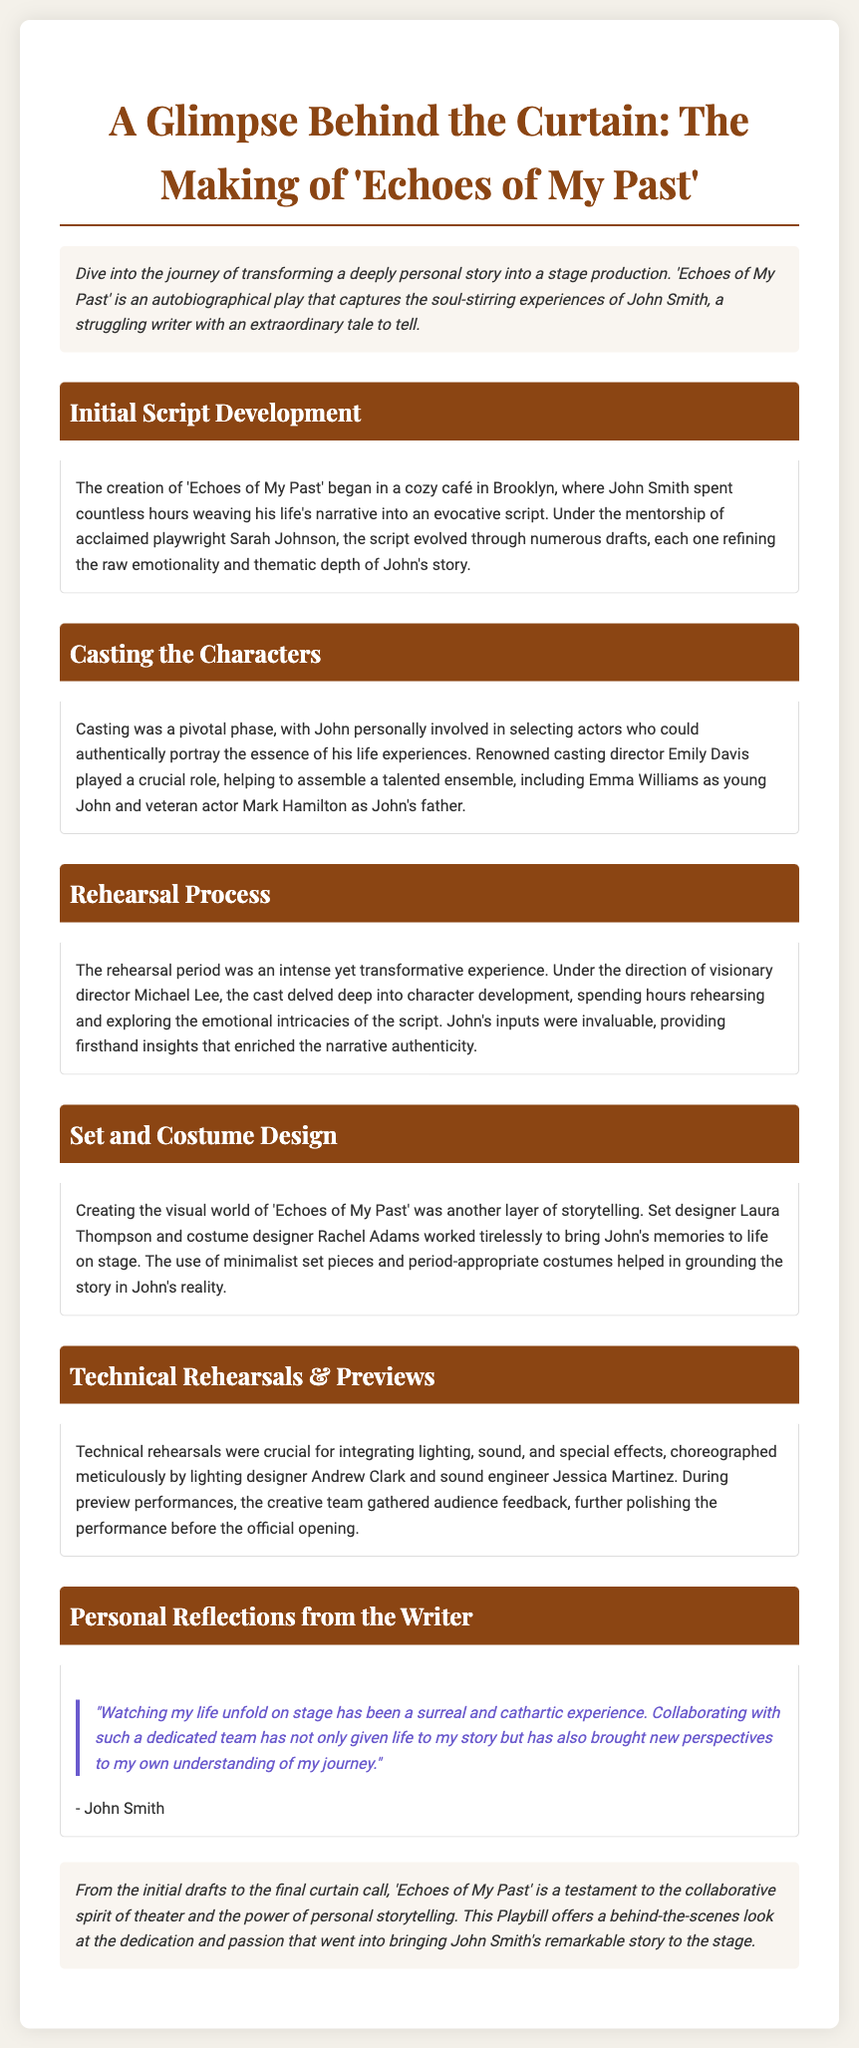What is the title of the play? The title is mentioned prominently at the top of the document.
Answer: 'Echoes of My Past' Who is the playwright? The playwright is identified in the introduction section.
Answer: John Smith Which city was the initial script developed in? The location of initial script development is stated in the document.
Answer: Brooklyn Who mentored the playwright? The mentor of the playwright is specifically mentioned in the script development section.
Answer: Sarah Johnson What role did Emily Davis play in the production? The involvement of Emily Davis is detailed in the casting section.
Answer: Casting director What type of feedback was gathered during previews? The document mentions the purpose of gathering feedback during previews.
Answer: Audience feedback Which designer worked on the set? The set designer is listed in the set and costume design section.
Answer: Laura Thompson What is one personal reflection mentioned by the writer? A direct quote from the writer's reflections is provided.
Answer: Cathartic experience Who directed the play? The director's name is specified in the rehearsal process section.
Answer: Michael Lee 